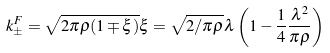Convert formula to latex. <formula><loc_0><loc_0><loc_500><loc_500>k ^ { F } _ { \pm } = \sqrt { 2 \pi \rho ( 1 \mp \xi ) } \xi = \sqrt { 2 / \pi \rho } \lambda \left ( 1 - \frac { 1 } { 4 } \frac { \lambda ^ { 2 } } { \pi \rho } \right )</formula> 